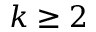<formula> <loc_0><loc_0><loc_500><loc_500>k \geq 2</formula> 